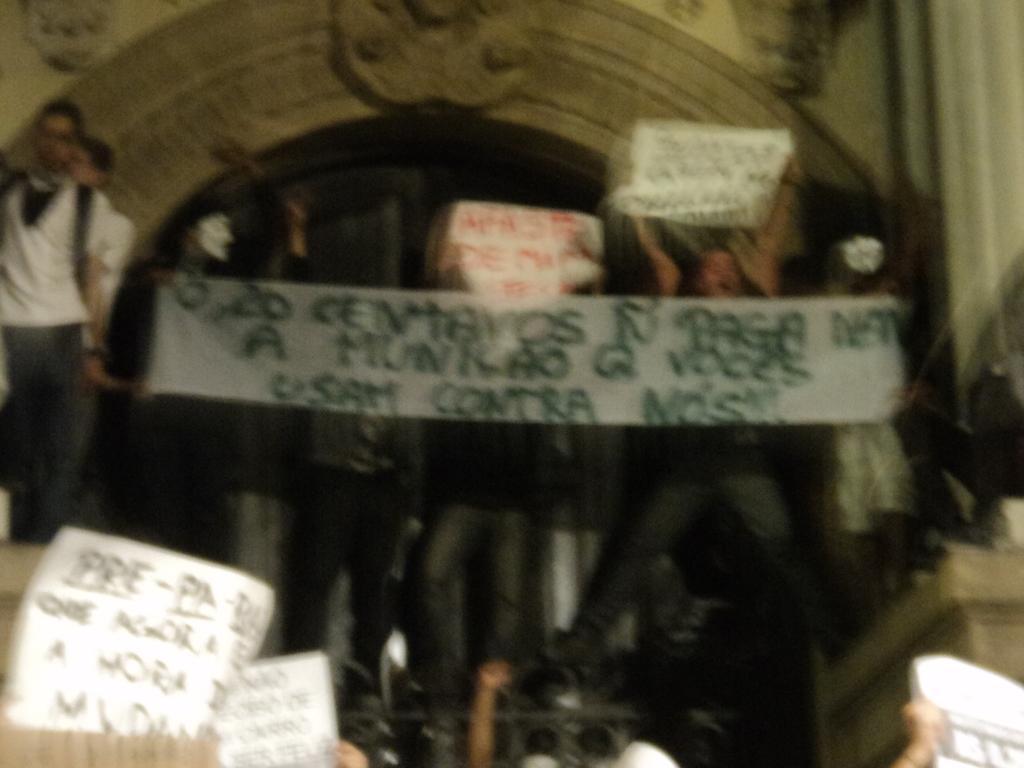How would you summarize this image in a sentence or two? It is a blur image. In this image, we can see a group of people. Few are holding banners. Here we can see wall and carvings. 